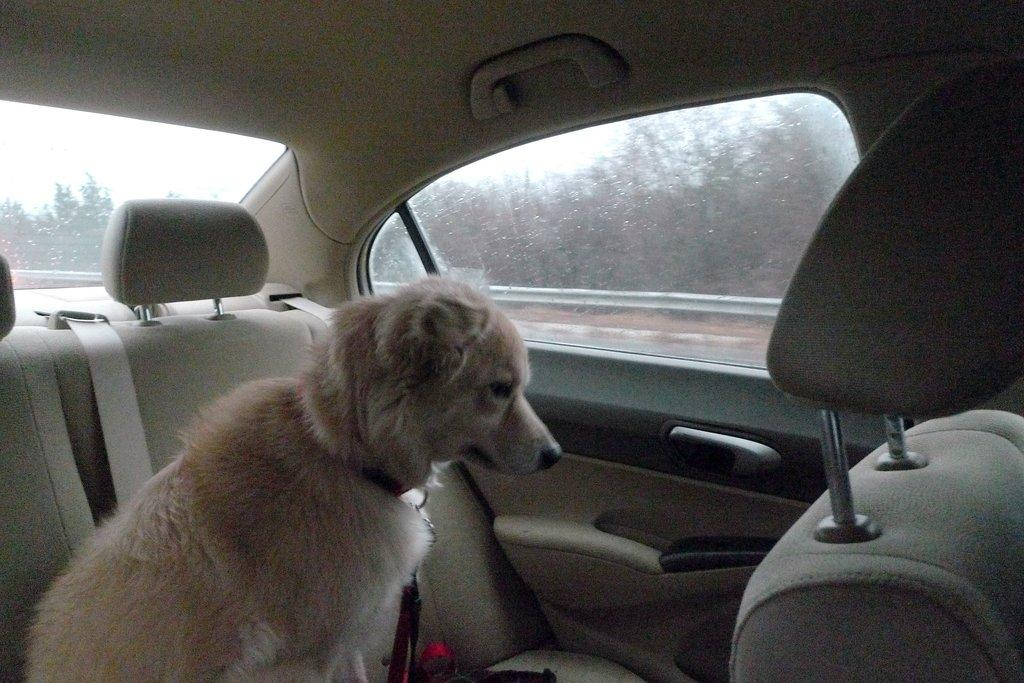What animal is present in the image? There is a dog in the image. Where is the dog located? The dog is in a vehicle. What can be seen in the background of the image? There are trees in the background of the image. What type of invention is the dog holding in the image? There is no invention present in the image, and the dog is not holding anything. 